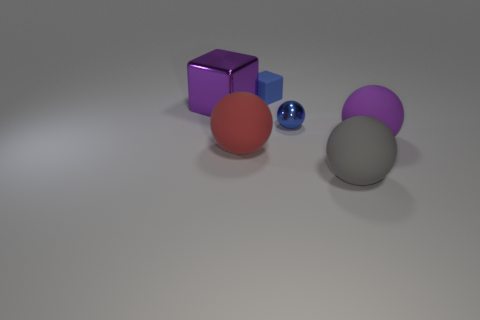Subtract all blue spheres. How many spheres are left? 3 Subtract all blue metal balls. How many balls are left? 3 Subtract all yellow spheres. Subtract all green blocks. How many spheres are left? 4 Add 1 tiny cubes. How many objects exist? 7 Subtract 1 purple spheres. How many objects are left? 5 Subtract all blocks. How many objects are left? 4 Subtract all blue balls. Subtract all small cyan shiny cubes. How many objects are left? 5 Add 3 purple matte spheres. How many purple matte spheres are left? 4 Add 2 big purple cubes. How many big purple cubes exist? 3 